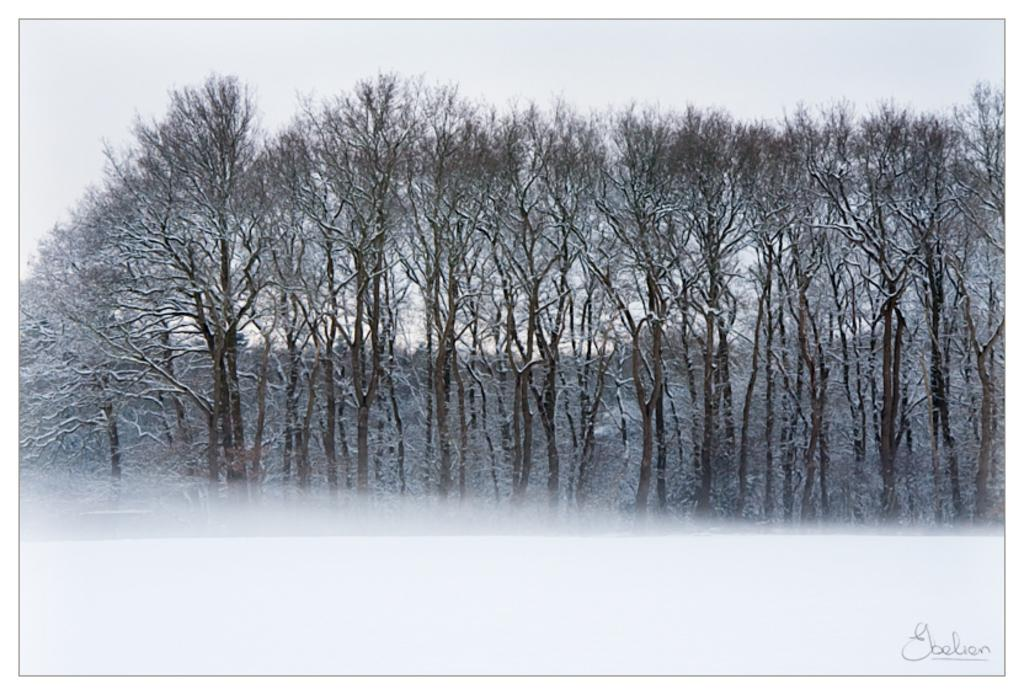What type of vegetation can be seen in the image? There are trees in the image. What part of the natural environment is visible in the image? The sky is visible in the image. Is there any text present in the image? Yes, there is text at the bottom of the image. What type of pickle is being used to solve arithmetic problems in the image? There is no pickle present in the image, nor are there any arithmetic problems depicted. 